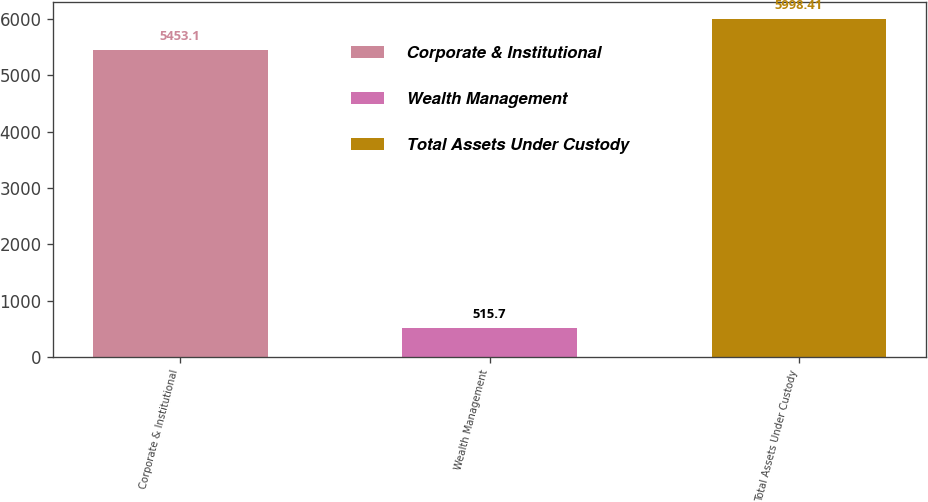<chart> <loc_0><loc_0><loc_500><loc_500><bar_chart><fcel>Corporate & Institutional<fcel>Wealth Management<fcel>Total Assets Under Custody<nl><fcel>5453.1<fcel>515.7<fcel>5998.41<nl></chart> 